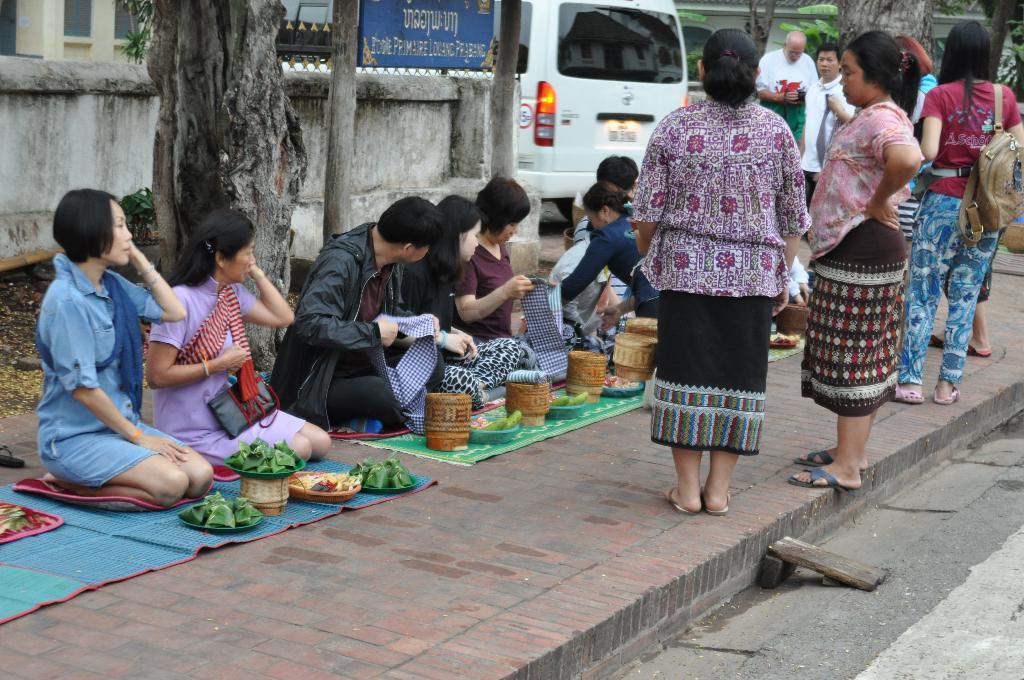Describe this image in one or two sentences. In this picture we can observe some people sitting on the footpath. In front of them we can observe some bowls. There were men and women in this picture. There are some people standing. on the left side there is a tree and a wall. We can observe a white color vehicle. There is a building. 